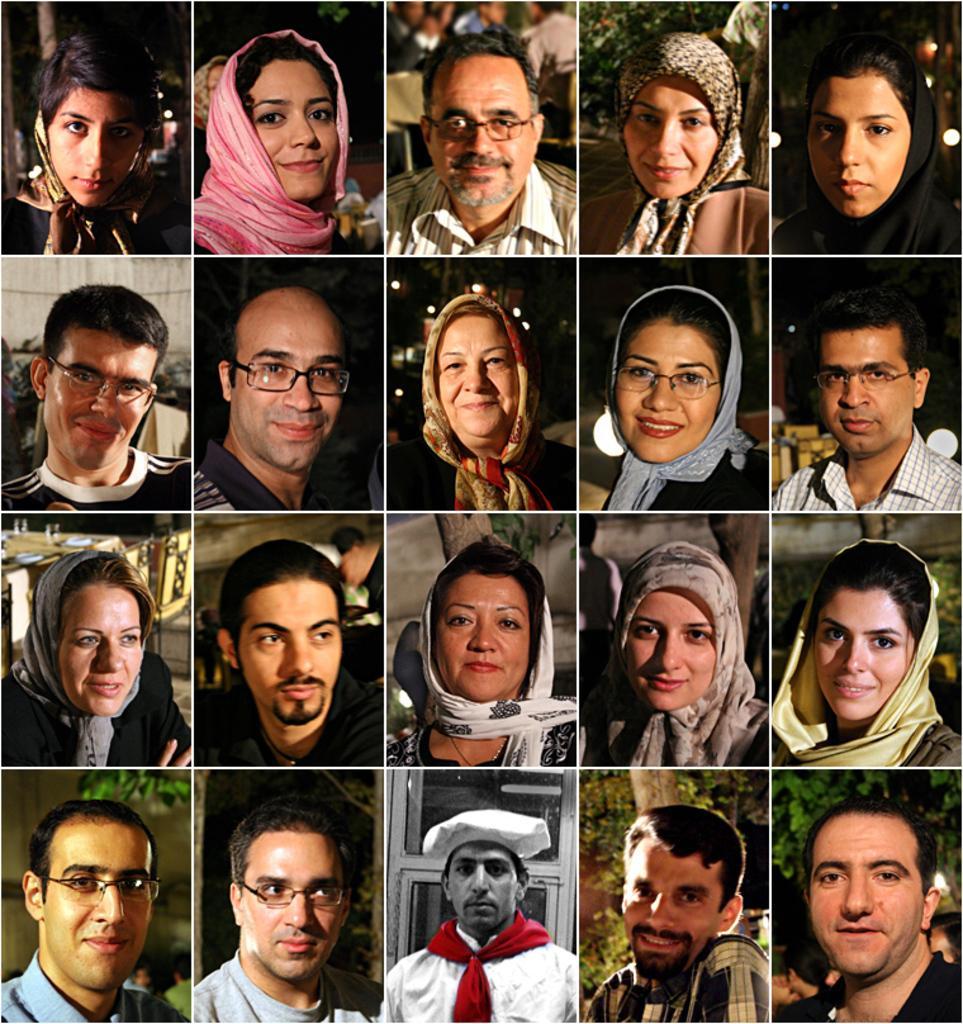Can you describe this image briefly? In this image I can see a collage of many images. There are images of people. 